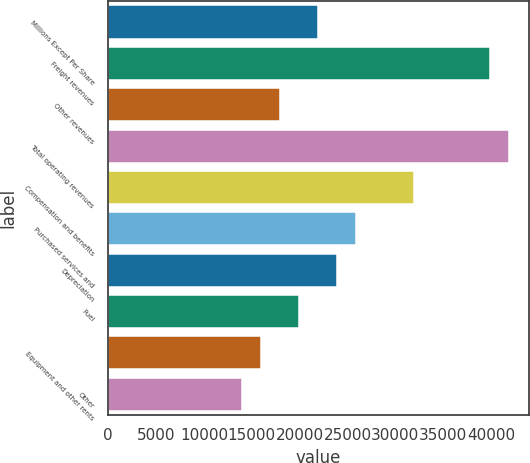Convert chart. <chart><loc_0><loc_0><loc_500><loc_500><bar_chart><fcel>Millions Except Per Share<fcel>Freight revenues<fcel>Other revenues<fcel>Total operating revenues<fcel>Compensation and benefits<fcel>Purchased services and<fcel>Depreciation<fcel>Fuel<fcel>Equipment and other rents<fcel>Other<nl><fcel>21934.8<fcel>39879.7<fcel>17947.1<fcel>41873.6<fcel>31904.2<fcel>25922.6<fcel>23928.7<fcel>19941<fcel>15953.2<fcel>13959.4<nl></chart> 